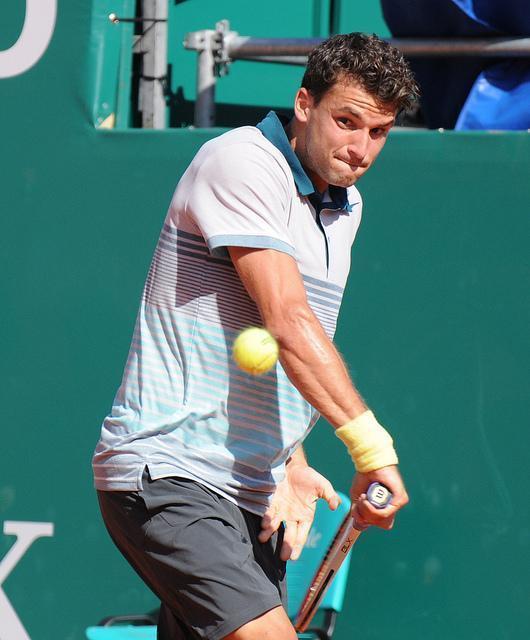What technique does this player utilize here?
Pick the right solution, then justify: 'Answer: answer
Rationale: rationale.'
Options: Underhanded, avoidance, overhanded, back handed. Answer: back handed.
Rationale: The players wrist is backwards and it is a typical motion of a band handed swing. What manner will the person here hit the ball?
Make your selection from the four choices given to correctly answer the question.
Options: Forehanded, head butt, two handed, backhanded. Backhanded. 